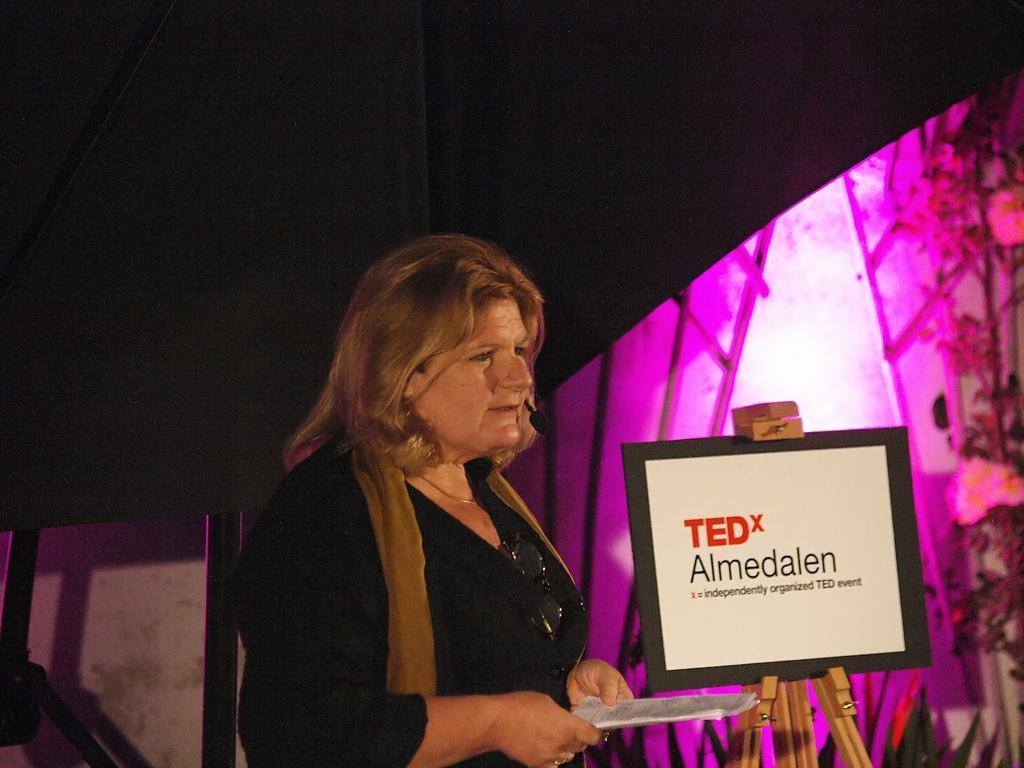Describe this image in one or two sentences. In this picture there is a woman standing and holding the paper. There is a board and there is text on the board. At the back there are plants and their might be a light and there is a black color object. 